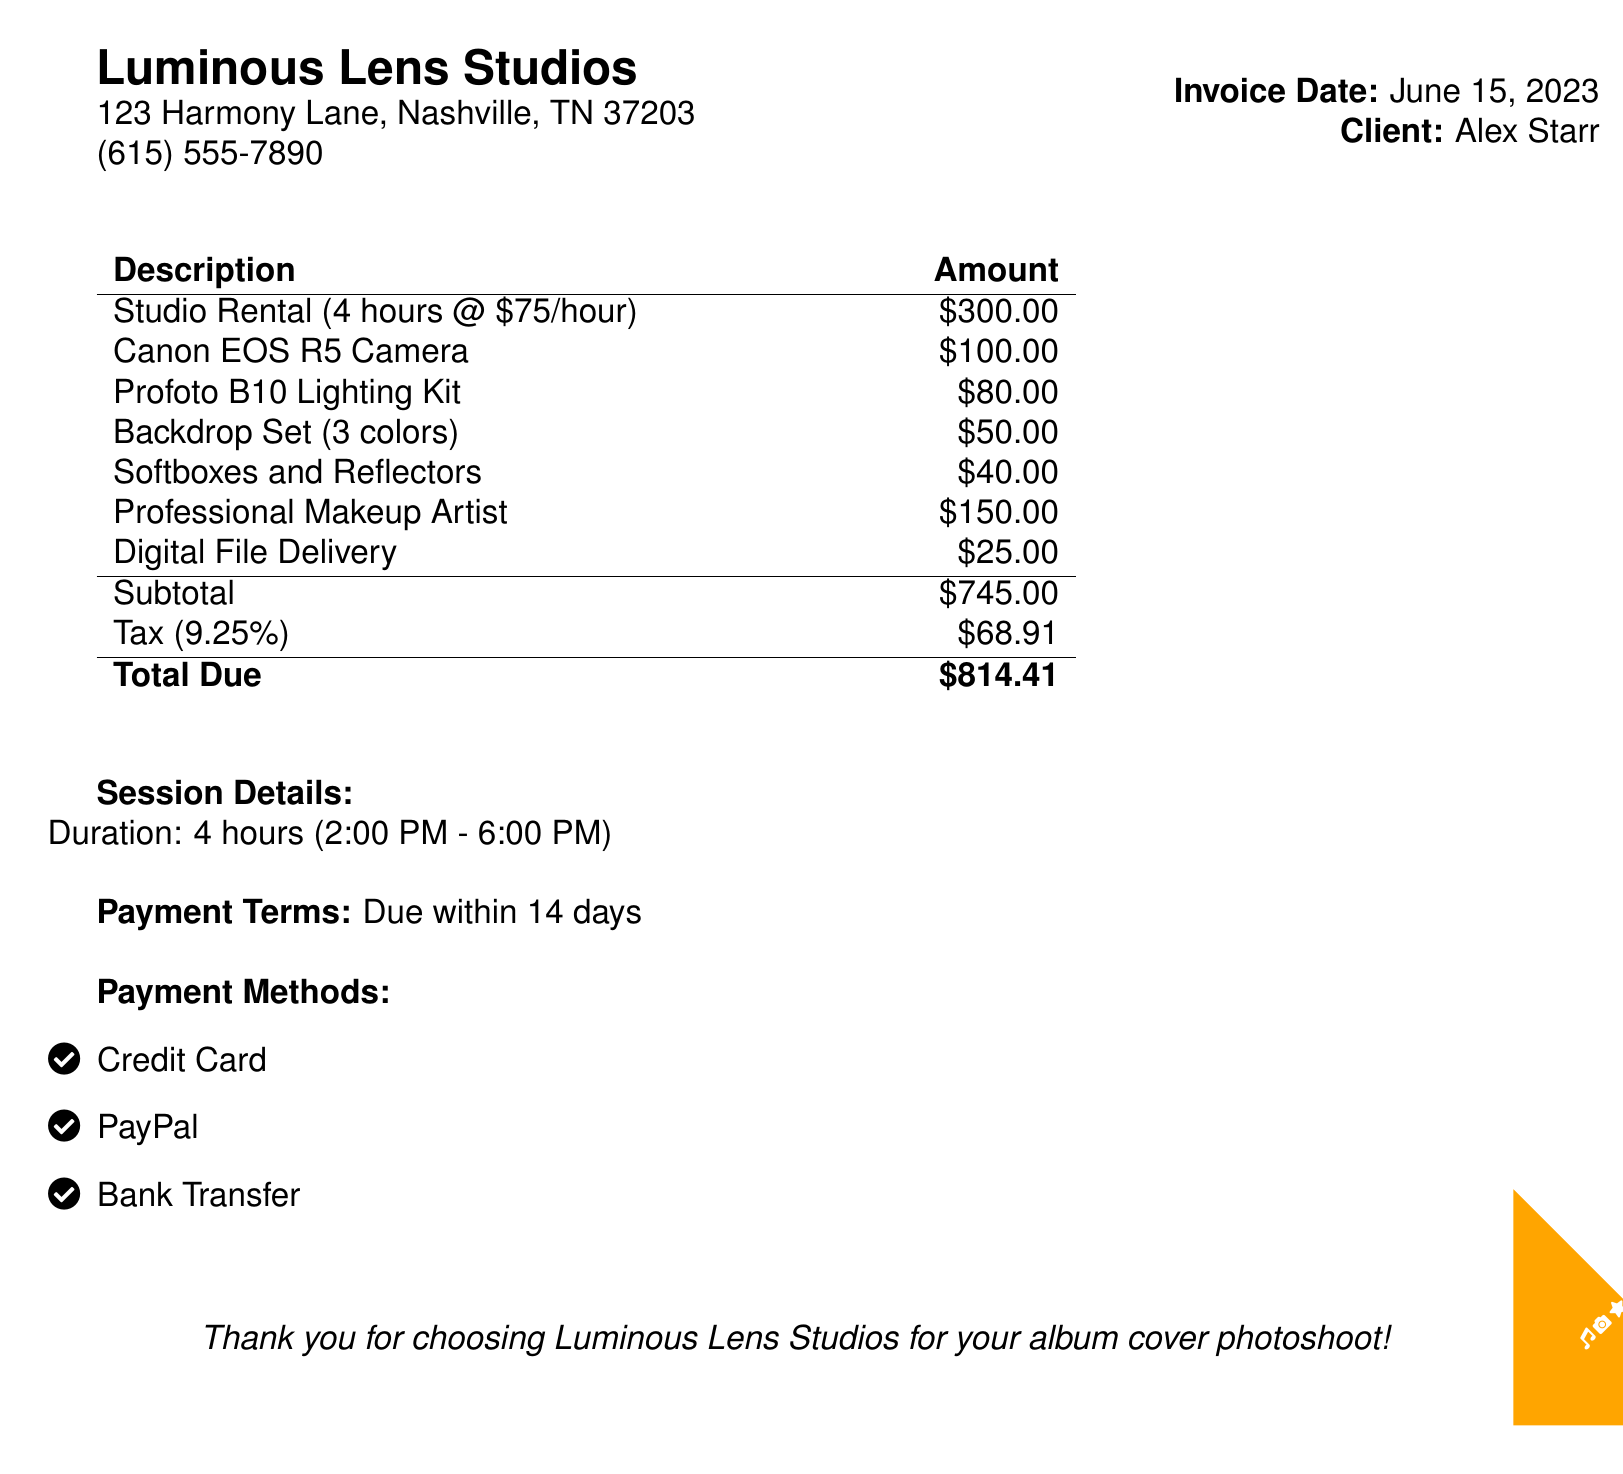What is the invoice date? The invoice date is specified in the document and is June 15, 2023.
Answer: June 15, 2023 What is the total amount due? The total due is clearly listed in the table as the final summary of costs.
Answer: $814.41 How much does the studio rental cost per hour? The hour rate for studio rental can be calculated from the rental line and indicates $75/hour.
Answer: $75/hour What is the tax rate applied? The tax percentage is mentioned in the subtotal section as 9.25%.
Answer: 9.25% How long was the photoshoot session? The duration of the session is mentioned directly in the session details and is 4 hours.
Answer: 4 hours What services were included in the rental? The included services are listed under the description section in the table.
Answer: Studio Rental, Camera, Lighting Kit, Backdrop Set, Softboxes, Makeup Artist, Digital File Delivery What payment methods are accepted? The document provides a list of acceptable payment methods.
Answer: Credit Card, PayPal, Bank Transfer What is the name of the studio? The studio's name is mentioned at the beginning of the document.
Answer: Luminous Lens Studios 